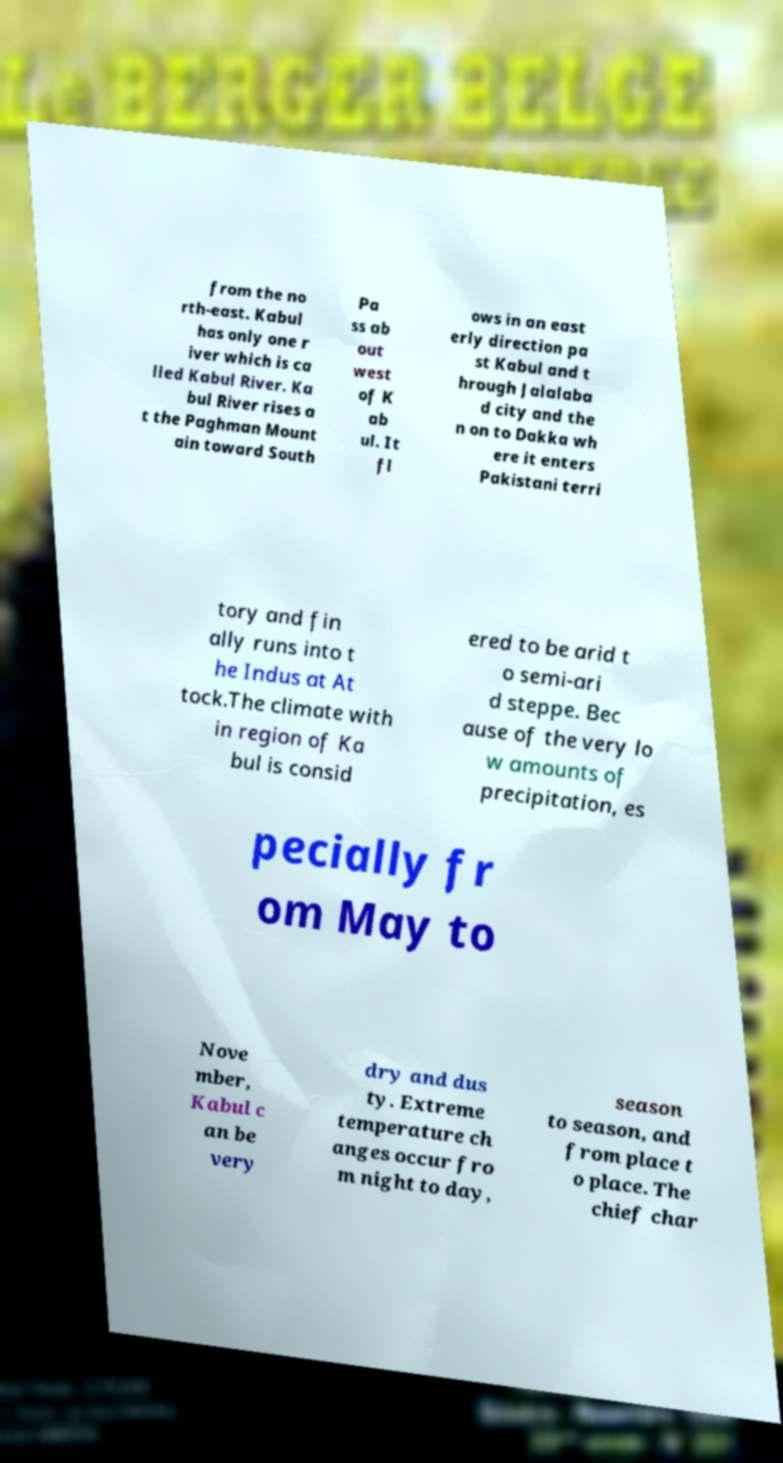Can you read and provide the text displayed in the image?This photo seems to have some interesting text. Can you extract and type it out for me? from the no rth-east. Kabul has only one r iver which is ca lled Kabul River. Ka bul River rises a t the Paghman Mount ain toward South Pa ss ab out west of K ab ul. It fl ows in an east erly direction pa st Kabul and t hrough Jalalaba d city and the n on to Dakka wh ere it enters Pakistani terri tory and fin ally runs into t he Indus at At tock.The climate with in region of Ka bul is consid ered to be arid t o semi-ari d steppe. Bec ause of the very lo w amounts of precipitation, es pecially fr om May to Nove mber, Kabul c an be very dry and dus ty. Extreme temperature ch anges occur fro m night to day, season to season, and from place t o place. The chief char 